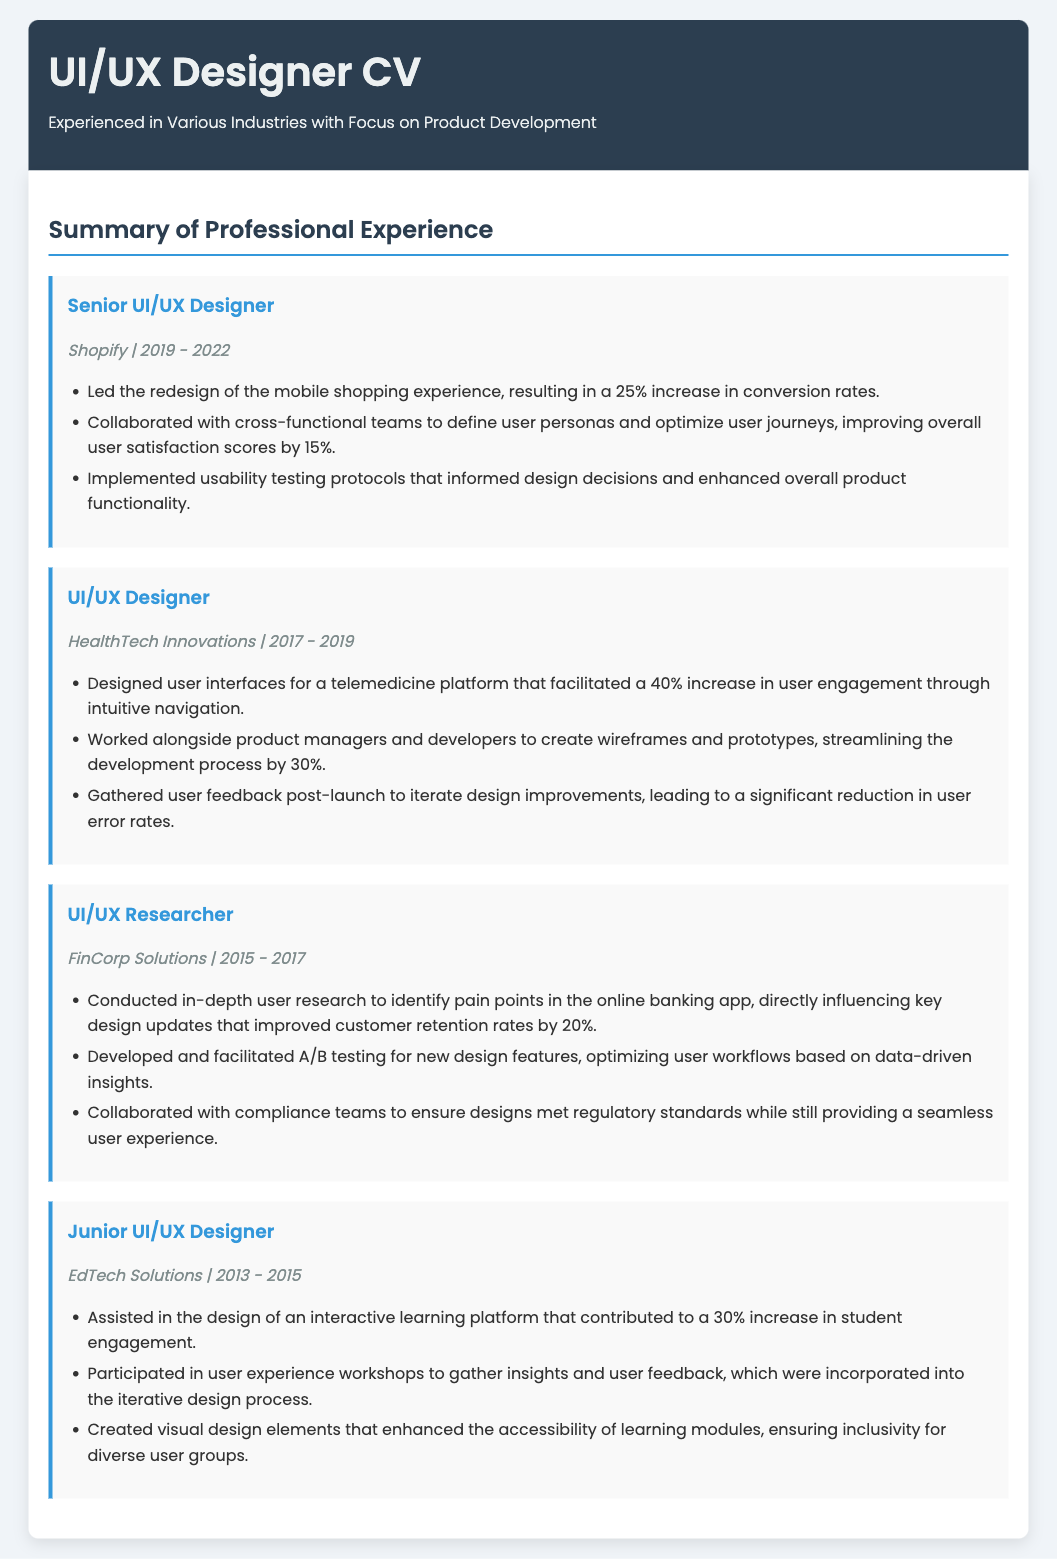What is the role of the candidate at Shopify? The candidate's role at Shopify is described as "Senior UI/UX Designer."
Answer: Senior UI/UX Designer What was the percentage increase in conversion rates after the redesign at Shopify? The document states that the redesign resulted in a "25% increase in conversion rates."
Answer: 25% During which years did the candidate work at HealthTech Innovations? The document lists the candidate's tenure at HealthTech Innovations as "2017 - 2019."
Answer: 2017 - 2019 What key feature did the telemedicine platform design improve according to the HealthTech Innovations role? The design facilitated a "40% increase in user engagement."
Answer: 40% How much did the user satisfaction scores improve at Shopify? The document mentions an improvement of "15%" in user satisfaction scores.
Answer: 15% What was one major contribution during the candidate's role as a UI/UX Researcher at FinCorp Solutions? The candidate's research directly influenced "key design updates" that improved customer retention rates.
Answer: key design updates What type of design project did the candidate assist with at EdTech Solutions? The candidate assisted in the design of "an interactive learning platform."
Answer: an interactive learning platform How much did the design improvements reduce user error rates after launch at HealthTech Innovations? The document notes a "significant reduction in user error rates."
Answer: significant reduction What was the role-specific focus of the candidate's work across different positions? The focus across different roles was consistently on "product development."
Answer: product development 